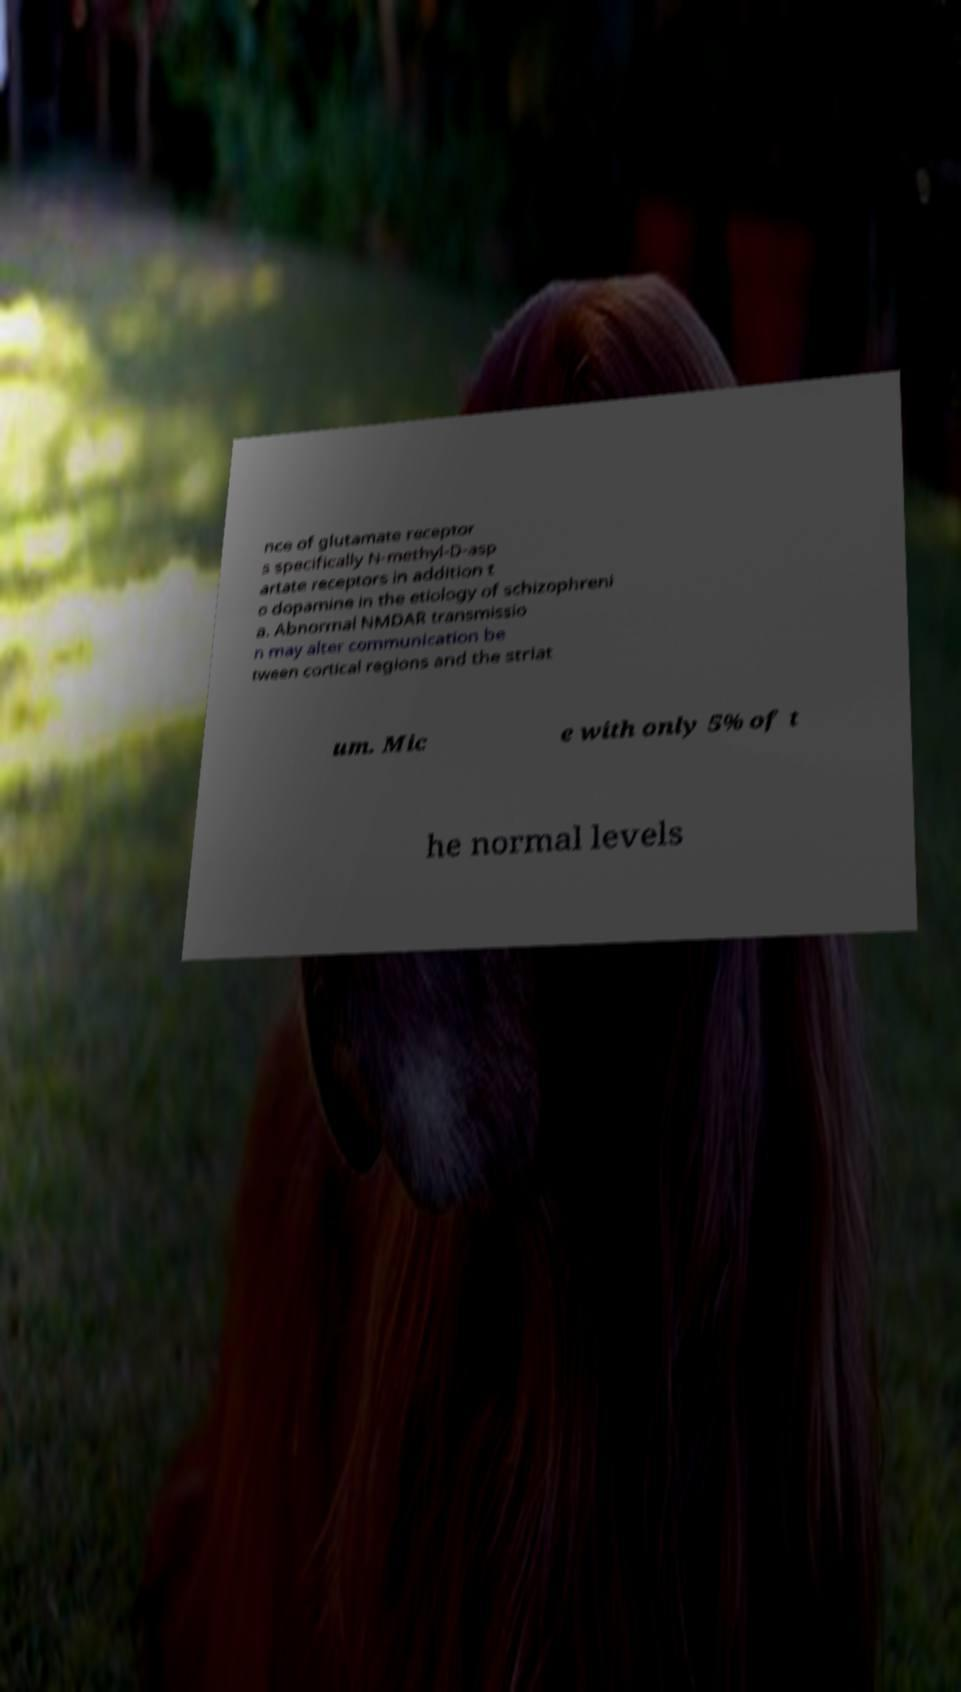Please read and relay the text visible in this image. What does it say? nce of glutamate receptor s specifically N-methyl-D-asp artate receptors in addition t o dopamine in the etiology of schizophreni a. Abnormal NMDAR transmissio n may alter communication be tween cortical regions and the striat um. Mic e with only 5% of t he normal levels 